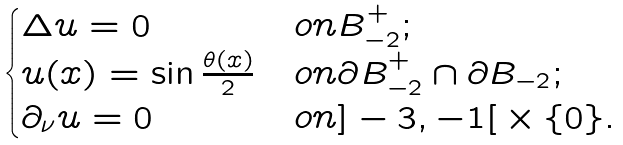<formula> <loc_0><loc_0><loc_500><loc_500>\begin{cases} \Delta u = 0 & o n B ^ { + } _ { - 2 } ; \\ u ( x ) = \sin \frac { \theta ( x ) } { 2 } & o n \partial B ^ { + } _ { - 2 } \cap \partial B _ { - 2 } ; \\ \partial _ { \nu } u = 0 & o n { ] - 3 , - 1 [ } \times \{ 0 \} . \end{cases}</formula> 